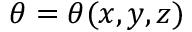<formula> <loc_0><loc_0><loc_500><loc_500>\theta = \theta ( x , y , z )</formula> 